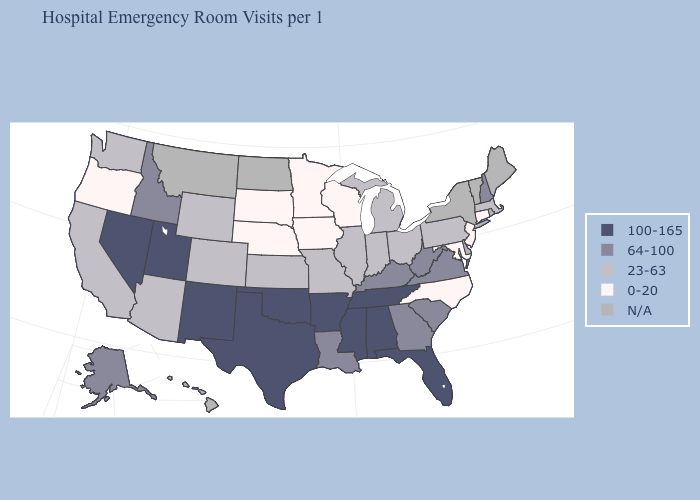What is the highest value in states that border Wyoming?
Keep it brief. 100-165. Name the states that have a value in the range N/A?
Write a very short answer. Delaware, Hawaii, Maine, Montana, New York, North Dakota, Rhode Island, Vermont. Does the first symbol in the legend represent the smallest category?
Give a very brief answer. No. Name the states that have a value in the range 100-165?
Quick response, please. Alabama, Arkansas, Florida, Mississippi, Nevada, New Mexico, Oklahoma, Tennessee, Texas, Utah. What is the value of Maine?
Quick response, please. N/A. Does the first symbol in the legend represent the smallest category?
Concise answer only. No. How many symbols are there in the legend?
Write a very short answer. 5. Among the states that border Ohio , does Kentucky have the lowest value?
Answer briefly. No. What is the highest value in states that border Kansas?
Keep it brief. 100-165. Which states hav the highest value in the MidWest?
Write a very short answer. Illinois, Indiana, Kansas, Michigan, Missouri, Ohio. Which states have the highest value in the USA?
Answer briefly. Alabama, Arkansas, Florida, Mississippi, Nevada, New Mexico, Oklahoma, Tennessee, Texas, Utah. What is the lowest value in the USA?
Be succinct. 0-20. Is the legend a continuous bar?
Short answer required. No. 